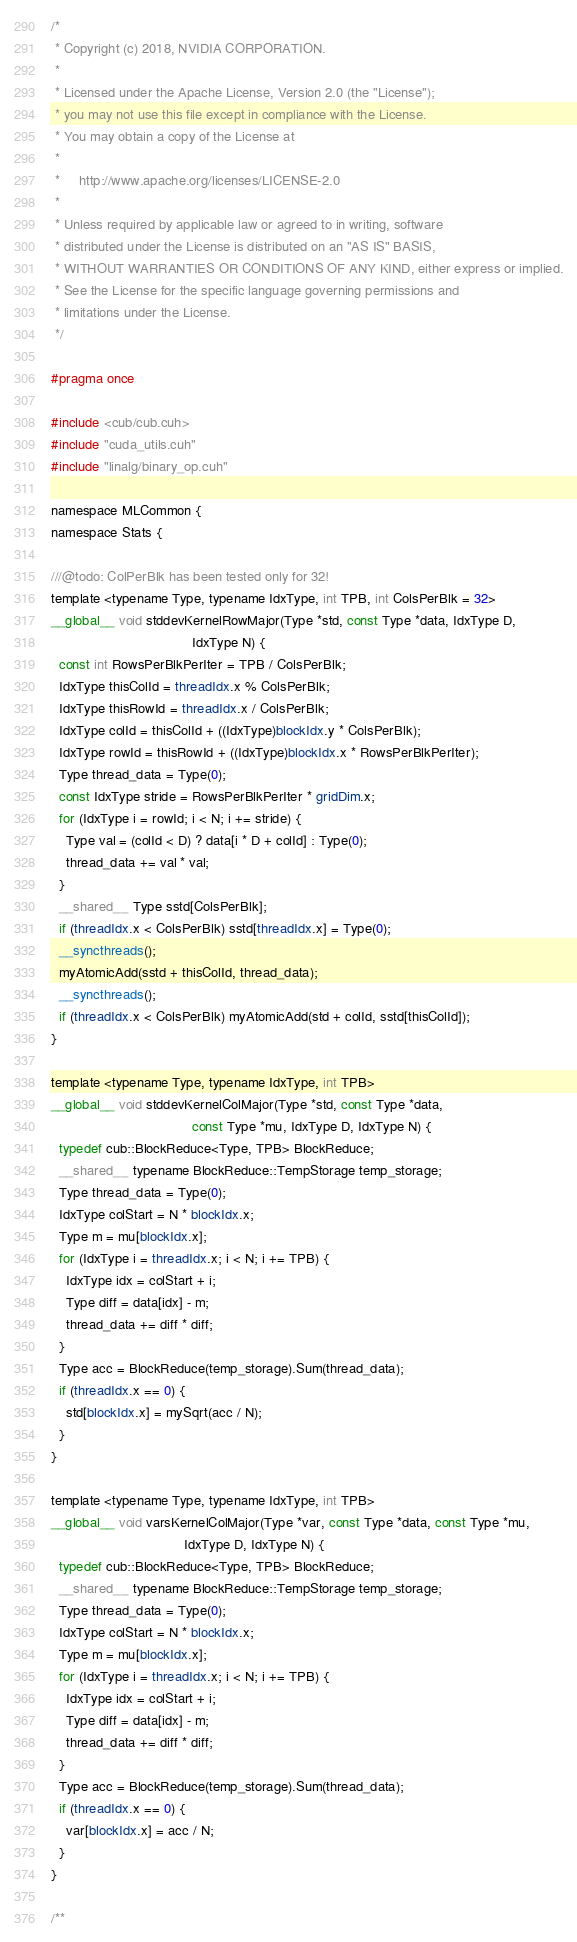Convert code to text. <code><loc_0><loc_0><loc_500><loc_500><_Cuda_>/*
 * Copyright (c) 2018, NVIDIA CORPORATION.
 *
 * Licensed under the Apache License, Version 2.0 (the "License");
 * you may not use this file except in compliance with the License.
 * You may obtain a copy of the License at
 *
 *     http://www.apache.org/licenses/LICENSE-2.0
 *
 * Unless required by applicable law or agreed to in writing, software
 * distributed under the License is distributed on an "AS IS" BASIS,
 * WITHOUT WARRANTIES OR CONDITIONS OF ANY KIND, either express or implied.
 * See the License for the specific language governing permissions and
 * limitations under the License.
 */

#pragma once

#include <cub/cub.cuh>
#include "cuda_utils.cuh"
#include "linalg/binary_op.cuh"

namespace MLCommon {
namespace Stats {

///@todo: ColPerBlk has been tested only for 32!
template <typename Type, typename IdxType, int TPB, int ColsPerBlk = 32>
__global__ void stddevKernelRowMajor(Type *std, const Type *data, IdxType D,
                                     IdxType N) {
  const int RowsPerBlkPerIter = TPB / ColsPerBlk;
  IdxType thisColId = threadIdx.x % ColsPerBlk;
  IdxType thisRowId = threadIdx.x / ColsPerBlk;
  IdxType colId = thisColId + ((IdxType)blockIdx.y * ColsPerBlk);
  IdxType rowId = thisRowId + ((IdxType)blockIdx.x * RowsPerBlkPerIter);
  Type thread_data = Type(0);
  const IdxType stride = RowsPerBlkPerIter * gridDim.x;
  for (IdxType i = rowId; i < N; i += stride) {
    Type val = (colId < D) ? data[i * D + colId] : Type(0);
    thread_data += val * val;
  }
  __shared__ Type sstd[ColsPerBlk];
  if (threadIdx.x < ColsPerBlk) sstd[threadIdx.x] = Type(0);
  __syncthreads();
  myAtomicAdd(sstd + thisColId, thread_data);
  __syncthreads();
  if (threadIdx.x < ColsPerBlk) myAtomicAdd(std + colId, sstd[thisColId]);
}

template <typename Type, typename IdxType, int TPB>
__global__ void stddevKernelColMajor(Type *std, const Type *data,
                                     const Type *mu, IdxType D, IdxType N) {
  typedef cub::BlockReduce<Type, TPB> BlockReduce;
  __shared__ typename BlockReduce::TempStorage temp_storage;
  Type thread_data = Type(0);
  IdxType colStart = N * blockIdx.x;
  Type m = mu[blockIdx.x];
  for (IdxType i = threadIdx.x; i < N; i += TPB) {
    IdxType idx = colStart + i;
    Type diff = data[idx] - m;
    thread_data += diff * diff;
  }
  Type acc = BlockReduce(temp_storage).Sum(thread_data);
  if (threadIdx.x == 0) {
    std[blockIdx.x] = mySqrt(acc / N);
  }
}

template <typename Type, typename IdxType, int TPB>
__global__ void varsKernelColMajor(Type *var, const Type *data, const Type *mu,
                                   IdxType D, IdxType N) {
  typedef cub::BlockReduce<Type, TPB> BlockReduce;
  __shared__ typename BlockReduce::TempStorage temp_storage;
  Type thread_data = Type(0);
  IdxType colStart = N * blockIdx.x;
  Type m = mu[blockIdx.x];
  for (IdxType i = threadIdx.x; i < N; i += TPB) {
    IdxType idx = colStart + i;
    Type diff = data[idx] - m;
    thread_data += diff * diff;
  }
  Type acc = BlockReduce(temp_storage).Sum(thread_data);
  if (threadIdx.x == 0) {
    var[blockIdx.x] = acc / N;
  }
}

/**</code> 